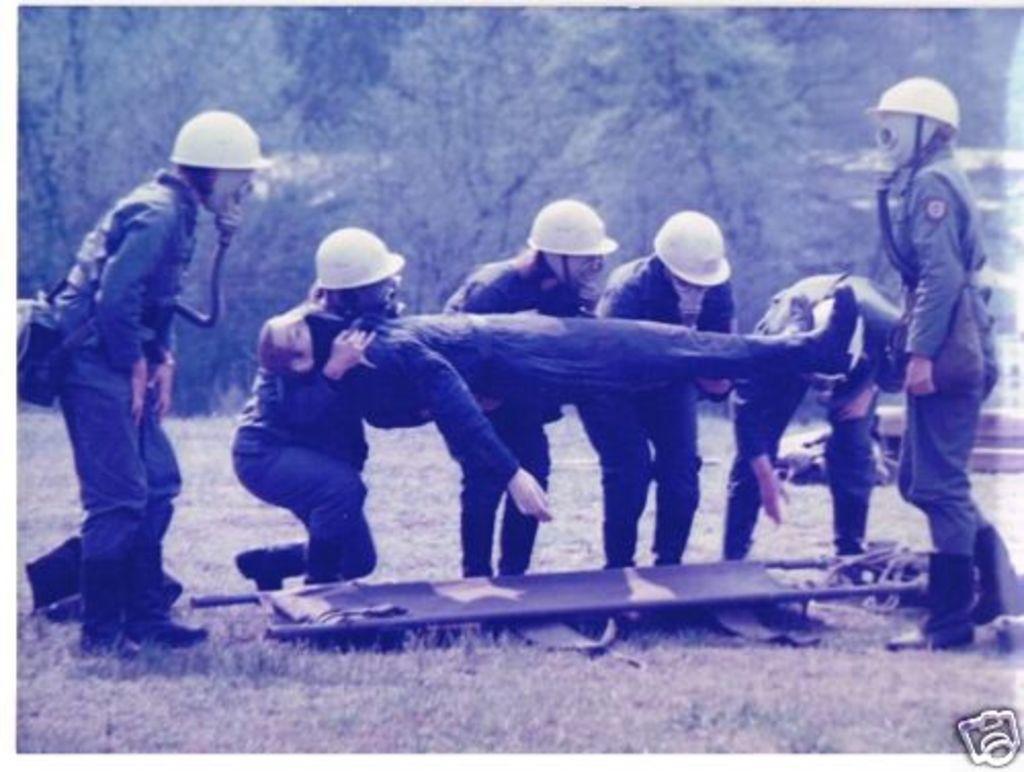Could you give a brief overview of what you see in this image? In this image I can see group of people standing and holding the other person. Background I can see trees and the image is in black and white. 